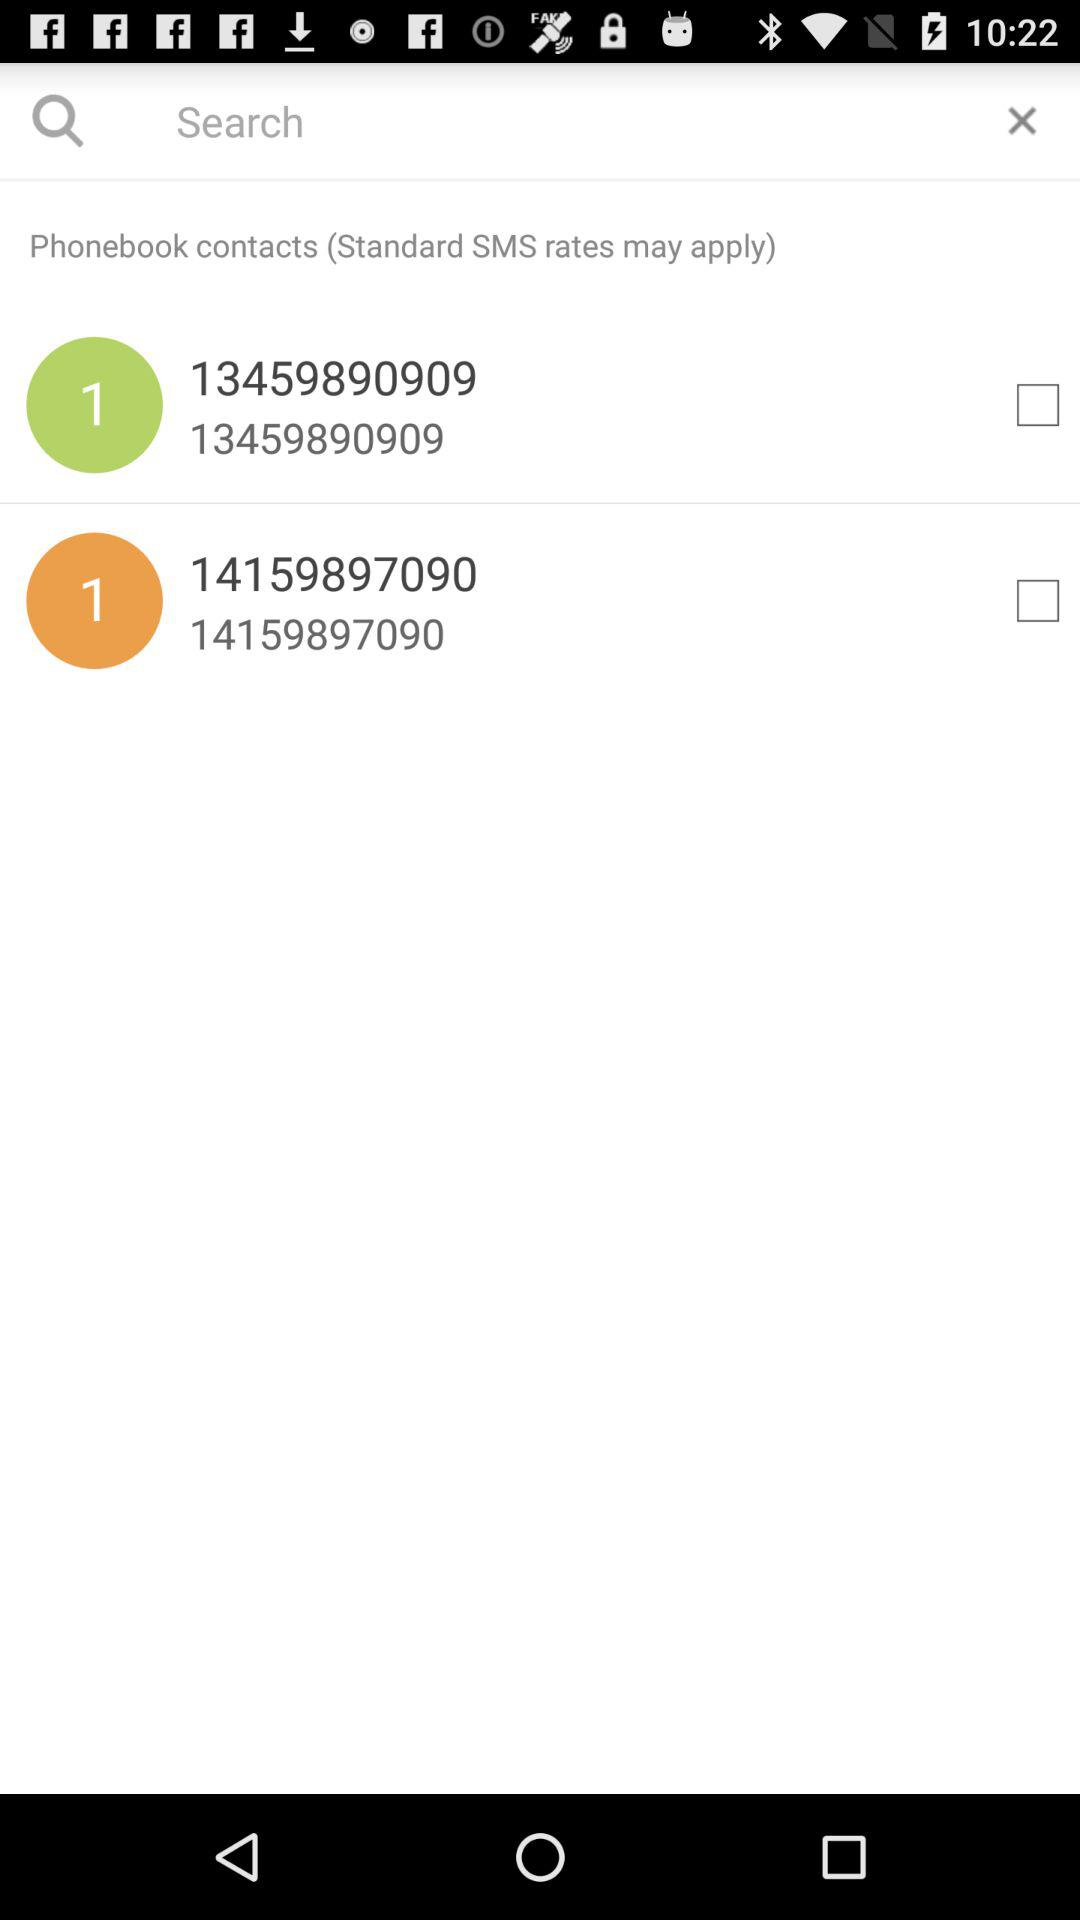Which contacts are not selected? The not selected contacts are 13459890909 and 14159897090. 